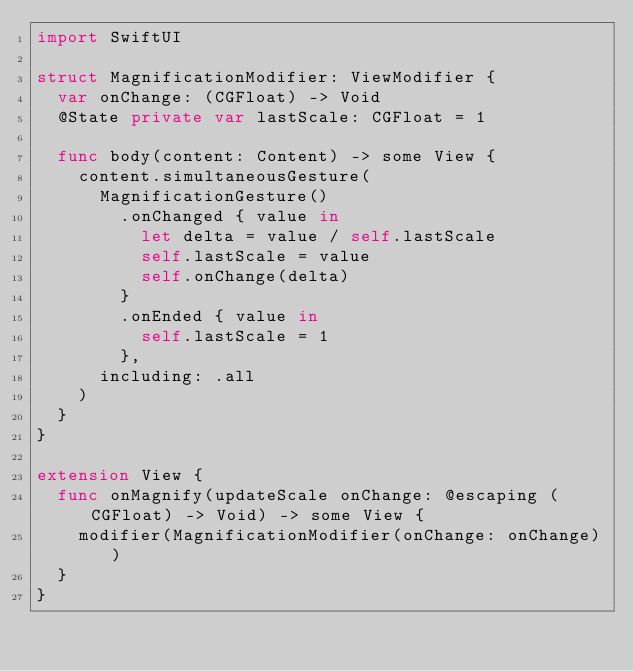<code> <loc_0><loc_0><loc_500><loc_500><_Swift_>import SwiftUI

struct MagnificationModifier: ViewModifier {
  var onChange: (CGFloat) -> Void
  @State private var lastScale: CGFloat = 1

  func body(content: Content) -> some View {
    content.simultaneousGesture(
      MagnificationGesture()
        .onChanged { value in
          let delta = value / self.lastScale
          self.lastScale = value
          self.onChange(delta)
        }
        .onEnded { value in
          self.lastScale = 1
        },
      including: .all
    )
  }
}

extension View {
  func onMagnify(updateScale onChange: @escaping (CGFloat) -> Void) -> some View {
    modifier(MagnificationModifier(onChange: onChange))
  }
}
</code> 